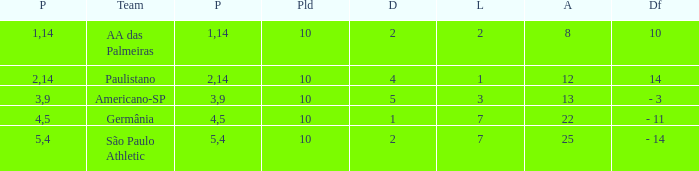What team has an against more than 8, lost of 7, and the position is 5? São Paulo Athletic. 